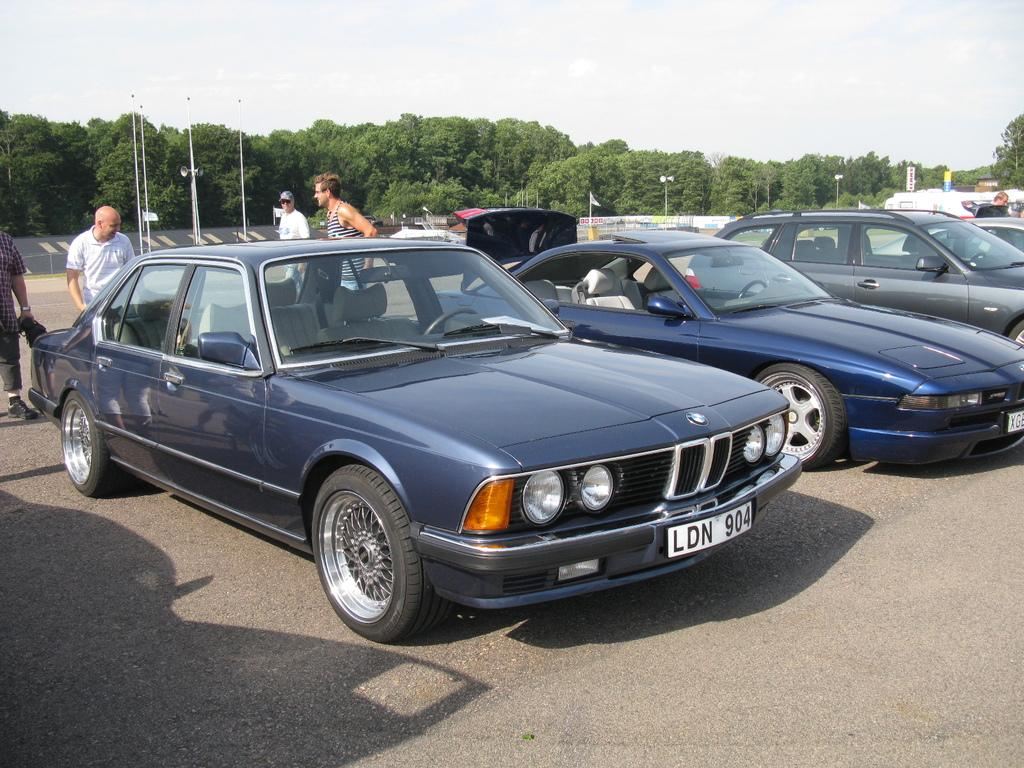What can be seen on the path in the image? There are vehicles parked on the path in the image. What is happening with the group of people in the image? There is a group of people standing in the image. What objects are present in the image that are used for support or guidance? There are poles in the image. What objects are present in the image that provide illumination? There are lights in the image. What objects are present in the image that are used for amplifying sound? There are megaphones in the image. What symbol or emblem can be seen in the image? There is a flag in the image. What type of natural vegetation is visible in the image? There are trees in the image. What is visible in the background of the image? The sky is visible in the background of the image. Where is the honey located in the image? There is no honey present in the image. What type of toy can be seen being used by the group of people in the image? There are no toys present in the image. 